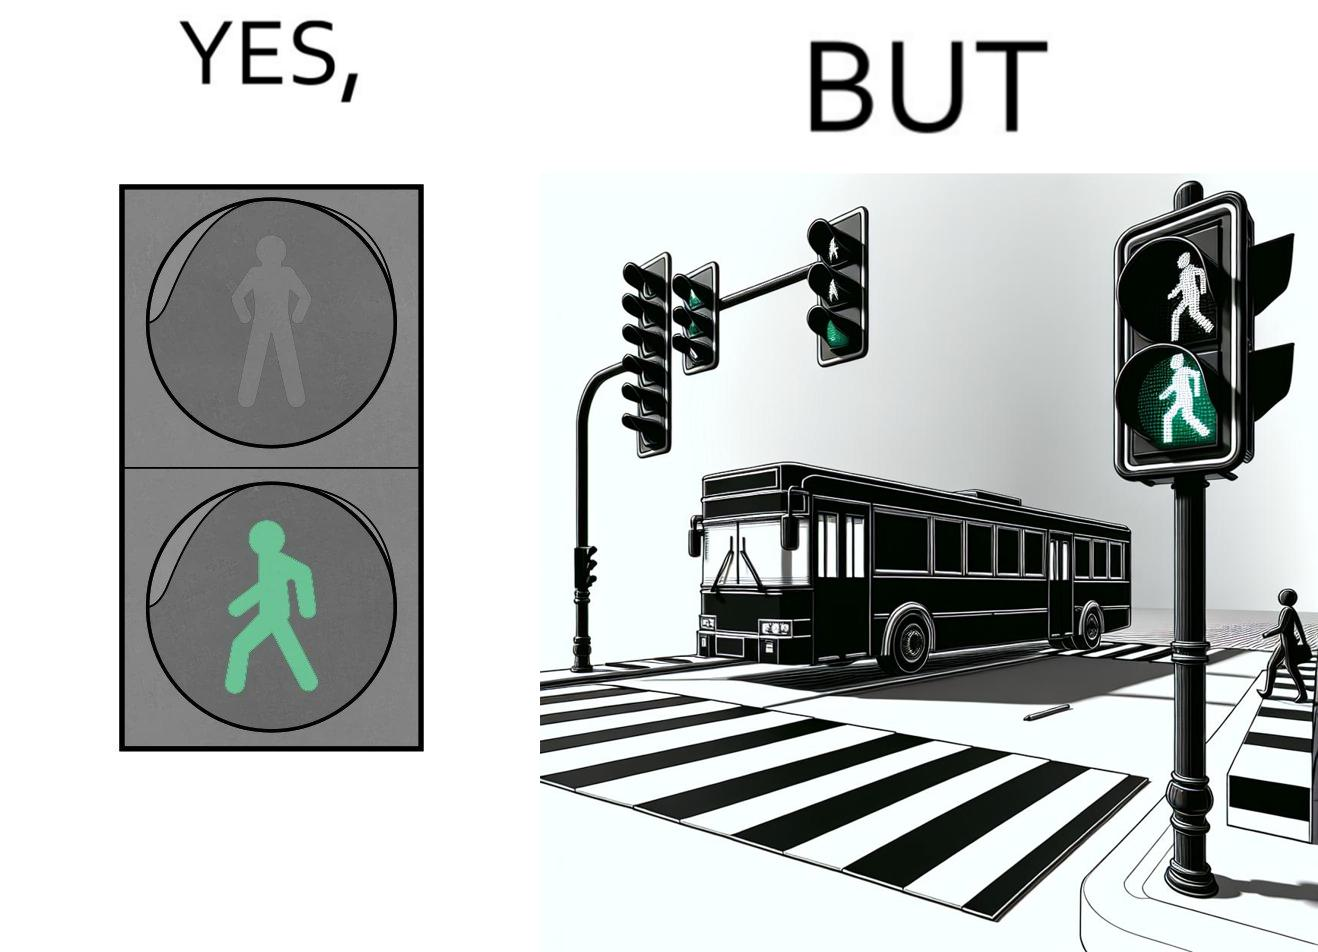Compare the left and right sides of this image. In the left part of the image: a traffic signal for the pedestrians and the signal is green, so pedestrians can cross the road In the right part of the image: a bus standing on the zebra crossing, while the traffic signal is green for the pedestrians symbolising  they can cross the road now 